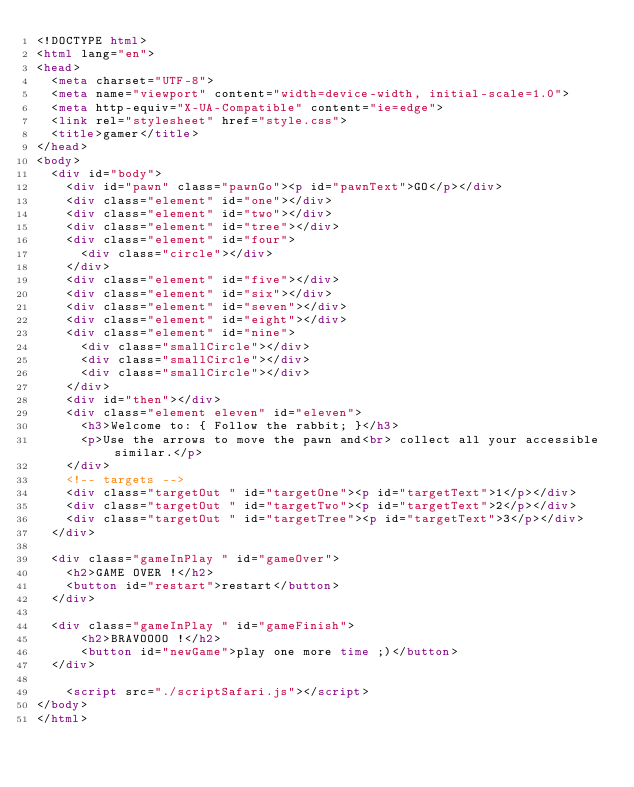Convert code to text. <code><loc_0><loc_0><loc_500><loc_500><_HTML_><!DOCTYPE html>
<html lang="en">
<head>
  <meta charset="UTF-8">
  <meta name="viewport" content="width=device-width, initial-scale=1.0">
  <meta http-equiv="X-UA-Compatible" content="ie=edge">
  <link rel="stylesheet" href="style.css">
  <title>gamer</title>
</head>
<body>
  <div id="body">
    <div id="pawn" class="pawnGo"><p id="pawnText">GO</p></div>
    <div class="element" id="one"></div>
    <div class="element" id="two"></div>
    <div class="element" id="tree"></div>
    <div class="element" id="four">
      <div class="circle"></div>
    </div>
    <div class="element" id="five"></div>
    <div class="element" id="six"></div>
    <div class="element" id="seven"></div>
    <div class="element" id="eight"></div>
    <div class="element" id="nine">
      <div class="smallCircle"></div>
      <div class="smallCircle"></div>
      <div class="smallCircle"></div>
    </div>
    <div id="then"></div>
    <div class="element eleven" id="eleven">
      <h3>Welcome to: { Follow the rabbit; }</h3>
      <p>Use the arrows to move the pawn and<br> collect all your accessible similar.</p>
    </div>
    <!-- targets -->
    <div class="targetOut " id="targetOne"><p id="targetText">1</p></div>
    <div class="targetOut " id="targetTwo"><p id="targetText">2</p></div>
    <div class="targetOut " id="targetTree"><p id="targetText">3</p></div>
  </div>

  <div class="gameInPlay " id="gameOver">
    <h2>GAME OVER !</h2>
    <button id="restart">restart</button>
  </div>

  <div class="gameInPlay " id="gameFinish">
      <h2>BRAVOOOO !</h2>
      <button id="newGame">play one more time ;)</button>
  </div>

    <script src="./scriptSafari.js"></script>
</body>
</html></code> 